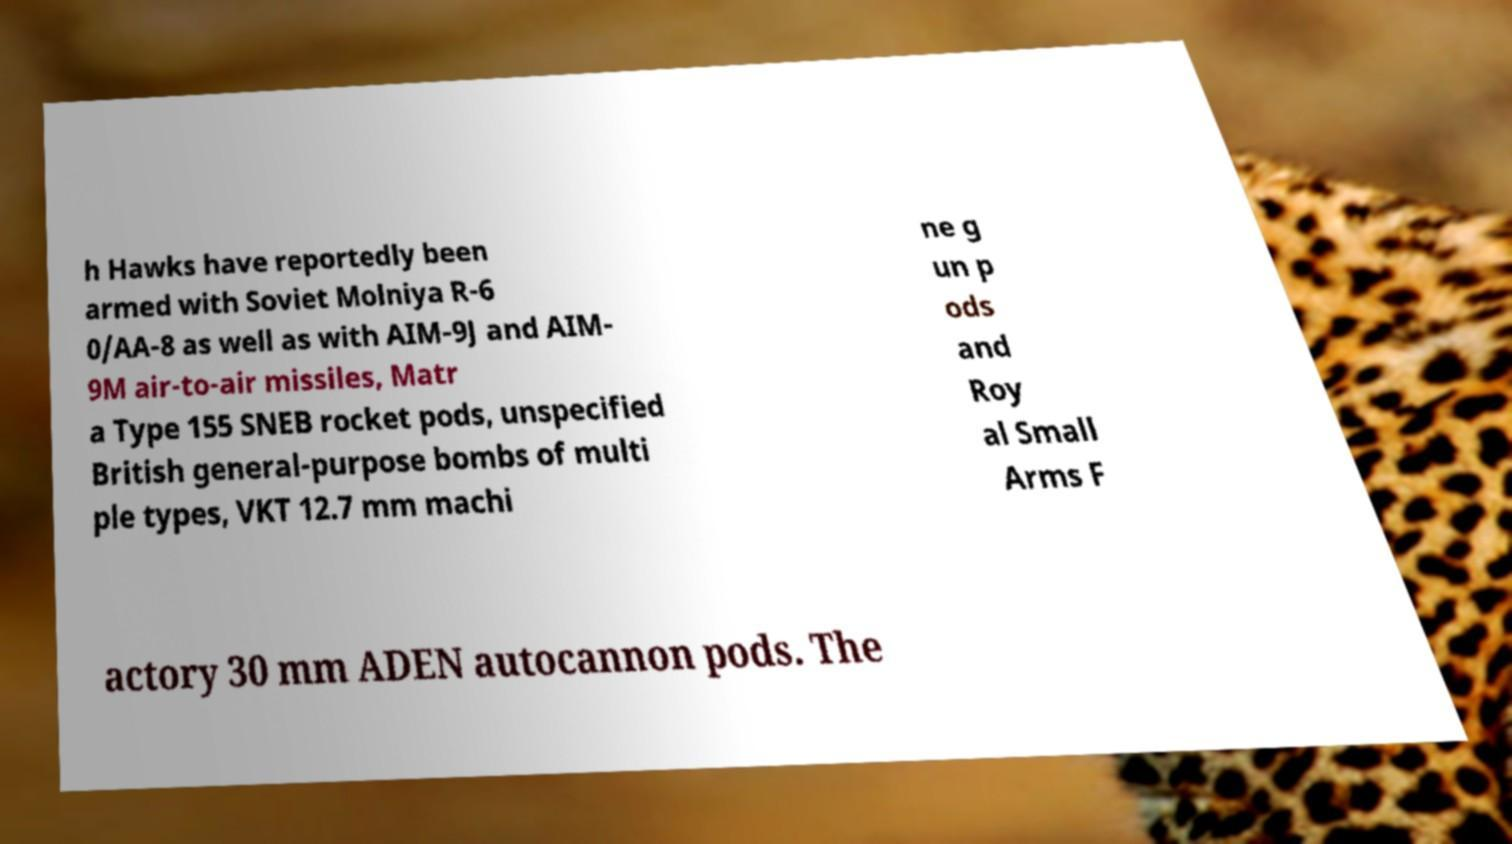Could you extract and type out the text from this image? h Hawks have reportedly been armed with Soviet Molniya R-6 0/AA-8 as well as with AIM-9J and AIM- 9M air-to-air missiles, Matr a Type 155 SNEB rocket pods, unspecified British general-purpose bombs of multi ple types, VKT 12.7 mm machi ne g un p ods and Roy al Small Arms F actory 30 mm ADEN autocannon pods. The 